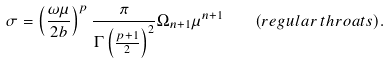<formula> <loc_0><loc_0><loc_500><loc_500>\sigma = \left ( { \frac { \omega \mu } { 2 b } } \right ) ^ { p } { \frac { \pi } { \Gamma \left ( { \frac { p + 1 } { 2 } } \right ) ^ { 2 } } } \Omega _ { n + 1 } \mu ^ { n + 1 } \quad ( r e g u l a r \, t h r o a t s ) .</formula> 